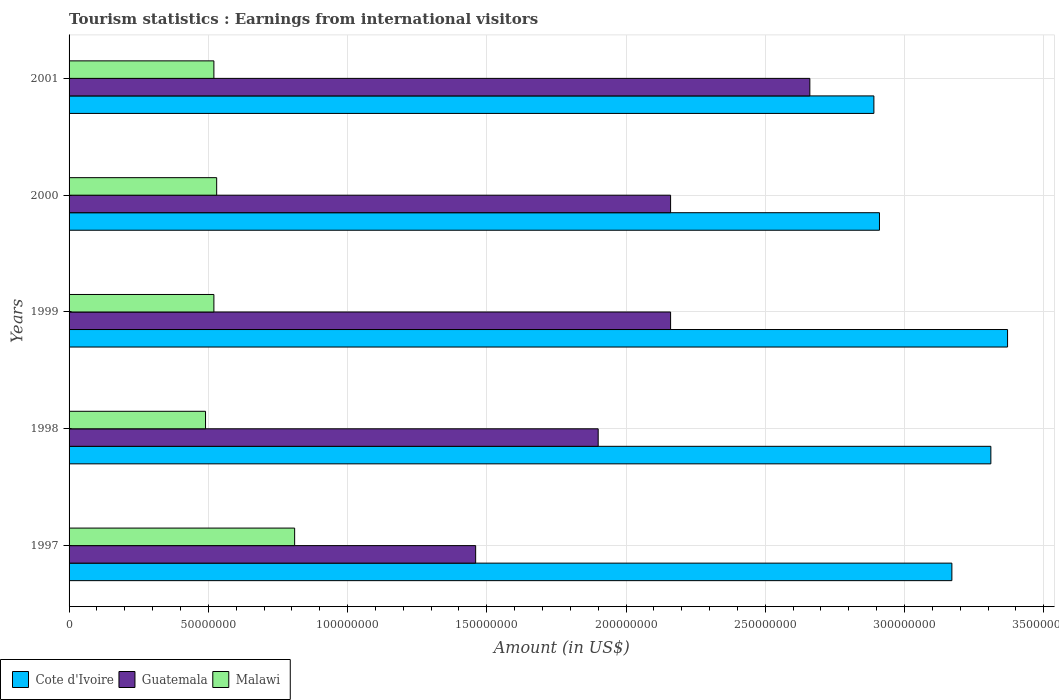How many different coloured bars are there?
Provide a succinct answer. 3. How many bars are there on the 5th tick from the top?
Your answer should be compact. 3. How many bars are there on the 3rd tick from the bottom?
Provide a short and direct response. 3. What is the earnings from international visitors in Malawi in 2000?
Your answer should be compact. 5.30e+07. Across all years, what is the maximum earnings from international visitors in Malawi?
Your answer should be compact. 8.10e+07. Across all years, what is the minimum earnings from international visitors in Malawi?
Your response must be concise. 4.90e+07. In which year was the earnings from international visitors in Malawi maximum?
Offer a terse response. 1997. What is the total earnings from international visitors in Cote d'Ivoire in the graph?
Your response must be concise. 1.56e+09. What is the difference between the earnings from international visitors in Malawi in 1997 and that in 2000?
Your response must be concise. 2.80e+07. What is the difference between the earnings from international visitors in Malawi in 1998 and the earnings from international visitors in Guatemala in 2001?
Your answer should be compact. -2.17e+08. What is the average earnings from international visitors in Cote d'Ivoire per year?
Ensure brevity in your answer.  3.13e+08. In the year 1998, what is the difference between the earnings from international visitors in Malawi and earnings from international visitors in Cote d'Ivoire?
Ensure brevity in your answer.  -2.82e+08. What is the ratio of the earnings from international visitors in Guatemala in 1998 to that in 2000?
Offer a terse response. 0.88. Is the earnings from international visitors in Cote d'Ivoire in 1998 less than that in 2001?
Make the answer very short. No. What is the difference between the highest and the lowest earnings from international visitors in Malawi?
Make the answer very short. 3.20e+07. In how many years, is the earnings from international visitors in Cote d'Ivoire greater than the average earnings from international visitors in Cote d'Ivoire taken over all years?
Ensure brevity in your answer.  3. Is the sum of the earnings from international visitors in Malawi in 2000 and 2001 greater than the maximum earnings from international visitors in Cote d'Ivoire across all years?
Give a very brief answer. No. What does the 3rd bar from the top in 2000 represents?
Give a very brief answer. Cote d'Ivoire. What does the 2nd bar from the bottom in 2000 represents?
Provide a succinct answer. Guatemala. Are all the bars in the graph horizontal?
Provide a short and direct response. Yes. How many years are there in the graph?
Offer a terse response. 5. Are the values on the major ticks of X-axis written in scientific E-notation?
Your answer should be very brief. No. Does the graph contain any zero values?
Keep it short and to the point. No. Does the graph contain grids?
Give a very brief answer. Yes. How are the legend labels stacked?
Your answer should be compact. Horizontal. What is the title of the graph?
Make the answer very short. Tourism statistics : Earnings from international visitors. What is the label or title of the Y-axis?
Ensure brevity in your answer.  Years. What is the Amount (in US$) of Cote d'Ivoire in 1997?
Give a very brief answer. 3.17e+08. What is the Amount (in US$) in Guatemala in 1997?
Provide a short and direct response. 1.46e+08. What is the Amount (in US$) of Malawi in 1997?
Make the answer very short. 8.10e+07. What is the Amount (in US$) in Cote d'Ivoire in 1998?
Your answer should be very brief. 3.31e+08. What is the Amount (in US$) of Guatemala in 1998?
Your response must be concise. 1.90e+08. What is the Amount (in US$) of Malawi in 1998?
Provide a succinct answer. 4.90e+07. What is the Amount (in US$) of Cote d'Ivoire in 1999?
Offer a terse response. 3.37e+08. What is the Amount (in US$) in Guatemala in 1999?
Your answer should be very brief. 2.16e+08. What is the Amount (in US$) of Malawi in 1999?
Offer a terse response. 5.20e+07. What is the Amount (in US$) in Cote d'Ivoire in 2000?
Provide a succinct answer. 2.91e+08. What is the Amount (in US$) of Guatemala in 2000?
Your answer should be very brief. 2.16e+08. What is the Amount (in US$) of Malawi in 2000?
Make the answer very short. 5.30e+07. What is the Amount (in US$) of Cote d'Ivoire in 2001?
Give a very brief answer. 2.89e+08. What is the Amount (in US$) in Guatemala in 2001?
Make the answer very short. 2.66e+08. What is the Amount (in US$) in Malawi in 2001?
Keep it short and to the point. 5.20e+07. Across all years, what is the maximum Amount (in US$) of Cote d'Ivoire?
Your answer should be very brief. 3.37e+08. Across all years, what is the maximum Amount (in US$) of Guatemala?
Provide a succinct answer. 2.66e+08. Across all years, what is the maximum Amount (in US$) in Malawi?
Your response must be concise. 8.10e+07. Across all years, what is the minimum Amount (in US$) of Cote d'Ivoire?
Keep it short and to the point. 2.89e+08. Across all years, what is the minimum Amount (in US$) in Guatemala?
Your answer should be compact. 1.46e+08. Across all years, what is the minimum Amount (in US$) in Malawi?
Provide a short and direct response. 4.90e+07. What is the total Amount (in US$) in Cote d'Ivoire in the graph?
Your answer should be very brief. 1.56e+09. What is the total Amount (in US$) of Guatemala in the graph?
Provide a short and direct response. 1.03e+09. What is the total Amount (in US$) of Malawi in the graph?
Offer a terse response. 2.87e+08. What is the difference between the Amount (in US$) of Cote d'Ivoire in 1997 and that in 1998?
Make the answer very short. -1.40e+07. What is the difference between the Amount (in US$) in Guatemala in 1997 and that in 1998?
Ensure brevity in your answer.  -4.40e+07. What is the difference between the Amount (in US$) in Malawi in 1997 and that in 1998?
Ensure brevity in your answer.  3.20e+07. What is the difference between the Amount (in US$) in Cote d'Ivoire in 1997 and that in 1999?
Your answer should be very brief. -2.00e+07. What is the difference between the Amount (in US$) of Guatemala in 1997 and that in 1999?
Ensure brevity in your answer.  -7.00e+07. What is the difference between the Amount (in US$) of Malawi in 1997 and that in 1999?
Offer a very short reply. 2.90e+07. What is the difference between the Amount (in US$) of Cote d'Ivoire in 1997 and that in 2000?
Ensure brevity in your answer.  2.60e+07. What is the difference between the Amount (in US$) of Guatemala in 1997 and that in 2000?
Offer a terse response. -7.00e+07. What is the difference between the Amount (in US$) in Malawi in 1997 and that in 2000?
Give a very brief answer. 2.80e+07. What is the difference between the Amount (in US$) of Cote d'Ivoire in 1997 and that in 2001?
Provide a short and direct response. 2.80e+07. What is the difference between the Amount (in US$) of Guatemala in 1997 and that in 2001?
Your answer should be compact. -1.20e+08. What is the difference between the Amount (in US$) of Malawi in 1997 and that in 2001?
Offer a very short reply. 2.90e+07. What is the difference between the Amount (in US$) of Cote d'Ivoire in 1998 and that in 1999?
Your answer should be very brief. -6.00e+06. What is the difference between the Amount (in US$) of Guatemala in 1998 and that in 1999?
Ensure brevity in your answer.  -2.60e+07. What is the difference between the Amount (in US$) of Cote d'Ivoire in 1998 and that in 2000?
Your answer should be very brief. 4.00e+07. What is the difference between the Amount (in US$) of Guatemala in 1998 and that in 2000?
Your answer should be very brief. -2.60e+07. What is the difference between the Amount (in US$) in Malawi in 1998 and that in 2000?
Offer a terse response. -4.00e+06. What is the difference between the Amount (in US$) in Cote d'Ivoire in 1998 and that in 2001?
Provide a short and direct response. 4.20e+07. What is the difference between the Amount (in US$) in Guatemala in 1998 and that in 2001?
Offer a terse response. -7.60e+07. What is the difference between the Amount (in US$) of Malawi in 1998 and that in 2001?
Your response must be concise. -3.00e+06. What is the difference between the Amount (in US$) in Cote d'Ivoire in 1999 and that in 2000?
Provide a short and direct response. 4.60e+07. What is the difference between the Amount (in US$) of Guatemala in 1999 and that in 2000?
Your answer should be compact. 0. What is the difference between the Amount (in US$) in Cote d'Ivoire in 1999 and that in 2001?
Your answer should be very brief. 4.80e+07. What is the difference between the Amount (in US$) of Guatemala in 1999 and that in 2001?
Ensure brevity in your answer.  -5.00e+07. What is the difference between the Amount (in US$) in Malawi in 1999 and that in 2001?
Your answer should be compact. 0. What is the difference between the Amount (in US$) in Cote d'Ivoire in 2000 and that in 2001?
Your answer should be very brief. 2.00e+06. What is the difference between the Amount (in US$) in Guatemala in 2000 and that in 2001?
Make the answer very short. -5.00e+07. What is the difference between the Amount (in US$) of Malawi in 2000 and that in 2001?
Your answer should be very brief. 1.00e+06. What is the difference between the Amount (in US$) in Cote d'Ivoire in 1997 and the Amount (in US$) in Guatemala in 1998?
Provide a succinct answer. 1.27e+08. What is the difference between the Amount (in US$) in Cote d'Ivoire in 1997 and the Amount (in US$) in Malawi in 1998?
Your answer should be very brief. 2.68e+08. What is the difference between the Amount (in US$) in Guatemala in 1997 and the Amount (in US$) in Malawi in 1998?
Make the answer very short. 9.70e+07. What is the difference between the Amount (in US$) in Cote d'Ivoire in 1997 and the Amount (in US$) in Guatemala in 1999?
Your response must be concise. 1.01e+08. What is the difference between the Amount (in US$) of Cote d'Ivoire in 1997 and the Amount (in US$) of Malawi in 1999?
Provide a succinct answer. 2.65e+08. What is the difference between the Amount (in US$) of Guatemala in 1997 and the Amount (in US$) of Malawi in 1999?
Your answer should be compact. 9.40e+07. What is the difference between the Amount (in US$) of Cote d'Ivoire in 1997 and the Amount (in US$) of Guatemala in 2000?
Your answer should be very brief. 1.01e+08. What is the difference between the Amount (in US$) of Cote d'Ivoire in 1997 and the Amount (in US$) of Malawi in 2000?
Offer a terse response. 2.64e+08. What is the difference between the Amount (in US$) of Guatemala in 1997 and the Amount (in US$) of Malawi in 2000?
Your answer should be very brief. 9.30e+07. What is the difference between the Amount (in US$) in Cote d'Ivoire in 1997 and the Amount (in US$) in Guatemala in 2001?
Make the answer very short. 5.10e+07. What is the difference between the Amount (in US$) in Cote d'Ivoire in 1997 and the Amount (in US$) in Malawi in 2001?
Give a very brief answer. 2.65e+08. What is the difference between the Amount (in US$) in Guatemala in 1997 and the Amount (in US$) in Malawi in 2001?
Your answer should be very brief. 9.40e+07. What is the difference between the Amount (in US$) of Cote d'Ivoire in 1998 and the Amount (in US$) of Guatemala in 1999?
Make the answer very short. 1.15e+08. What is the difference between the Amount (in US$) in Cote d'Ivoire in 1998 and the Amount (in US$) in Malawi in 1999?
Your response must be concise. 2.79e+08. What is the difference between the Amount (in US$) of Guatemala in 1998 and the Amount (in US$) of Malawi in 1999?
Ensure brevity in your answer.  1.38e+08. What is the difference between the Amount (in US$) in Cote d'Ivoire in 1998 and the Amount (in US$) in Guatemala in 2000?
Give a very brief answer. 1.15e+08. What is the difference between the Amount (in US$) in Cote d'Ivoire in 1998 and the Amount (in US$) in Malawi in 2000?
Your answer should be compact. 2.78e+08. What is the difference between the Amount (in US$) in Guatemala in 1998 and the Amount (in US$) in Malawi in 2000?
Your response must be concise. 1.37e+08. What is the difference between the Amount (in US$) of Cote d'Ivoire in 1998 and the Amount (in US$) of Guatemala in 2001?
Your answer should be compact. 6.50e+07. What is the difference between the Amount (in US$) in Cote d'Ivoire in 1998 and the Amount (in US$) in Malawi in 2001?
Keep it short and to the point. 2.79e+08. What is the difference between the Amount (in US$) of Guatemala in 1998 and the Amount (in US$) of Malawi in 2001?
Make the answer very short. 1.38e+08. What is the difference between the Amount (in US$) in Cote d'Ivoire in 1999 and the Amount (in US$) in Guatemala in 2000?
Offer a terse response. 1.21e+08. What is the difference between the Amount (in US$) in Cote d'Ivoire in 1999 and the Amount (in US$) in Malawi in 2000?
Make the answer very short. 2.84e+08. What is the difference between the Amount (in US$) in Guatemala in 1999 and the Amount (in US$) in Malawi in 2000?
Provide a succinct answer. 1.63e+08. What is the difference between the Amount (in US$) of Cote d'Ivoire in 1999 and the Amount (in US$) of Guatemala in 2001?
Keep it short and to the point. 7.10e+07. What is the difference between the Amount (in US$) in Cote d'Ivoire in 1999 and the Amount (in US$) in Malawi in 2001?
Provide a succinct answer. 2.85e+08. What is the difference between the Amount (in US$) in Guatemala in 1999 and the Amount (in US$) in Malawi in 2001?
Provide a short and direct response. 1.64e+08. What is the difference between the Amount (in US$) in Cote d'Ivoire in 2000 and the Amount (in US$) in Guatemala in 2001?
Offer a very short reply. 2.50e+07. What is the difference between the Amount (in US$) in Cote d'Ivoire in 2000 and the Amount (in US$) in Malawi in 2001?
Your response must be concise. 2.39e+08. What is the difference between the Amount (in US$) of Guatemala in 2000 and the Amount (in US$) of Malawi in 2001?
Offer a very short reply. 1.64e+08. What is the average Amount (in US$) of Cote d'Ivoire per year?
Give a very brief answer. 3.13e+08. What is the average Amount (in US$) of Guatemala per year?
Your answer should be very brief. 2.07e+08. What is the average Amount (in US$) in Malawi per year?
Provide a short and direct response. 5.74e+07. In the year 1997, what is the difference between the Amount (in US$) in Cote d'Ivoire and Amount (in US$) in Guatemala?
Provide a short and direct response. 1.71e+08. In the year 1997, what is the difference between the Amount (in US$) in Cote d'Ivoire and Amount (in US$) in Malawi?
Your response must be concise. 2.36e+08. In the year 1997, what is the difference between the Amount (in US$) of Guatemala and Amount (in US$) of Malawi?
Provide a short and direct response. 6.50e+07. In the year 1998, what is the difference between the Amount (in US$) in Cote d'Ivoire and Amount (in US$) in Guatemala?
Give a very brief answer. 1.41e+08. In the year 1998, what is the difference between the Amount (in US$) of Cote d'Ivoire and Amount (in US$) of Malawi?
Your response must be concise. 2.82e+08. In the year 1998, what is the difference between the Amount (in US$) in Guatemala and Amount (in US$) in Malawi?
Your answer should be very brief. 1.41e+08. In the year 1999, what is the difference between the Amount (in US$) in Cote d'Ivoire and Amount (in US$) in Guatemala?
Offer a terse response. 1.21e+08. In the year 1999, what is the difference between the Amount (in US$) in Cote d'Ivoire and Amount (in US$) in Malawi?
Give a very brief answer. 2.85e+08. In the year 1999, what is the difference between the Amount (in US$) in Guatemala and Amount (in US$) in Malawi?
Give a very brief answer. 1.64e+08. In the year 2000, what is the difference between the Amount (in US$) of Cote d'Ivoire and Amount (in US$) of Guatemala?
Provide a succinct answer. 7.50e+07. In the year 2000, what is the difference between the Amount (in US$) of Cote d'Ivoire and Amount (in US$) of Malawi?
Your answer should be very brief. 2.38e+08. In the year 2000, what is the difference between the Amount (in US$) in Guatemala and Amount (in US$) in Malawi?
Offer a terse response. 1.63e+08. In the year 2001, what is the difference between the Amount (in US$) of Cote d'Ivoire and Amount (in US$) of Guatemala?
Offer a terse response. 2.30e+07. In the year 2001, what is the difference between the Amount (in US$) of Cote d'Ivoire and Amount (in US$) of Malawi?
Your answer should be compact. 2.37e+08. In the year 2001, what is the difference between the Amount (in US$) of Guatemala and Amount (in US$) of Malawi?
Make the answer very short. 2.14e+08. What is the ratio of the Amount (in US$) of Cote d'Ivoire in 1997 to that in 1998?
Your answer should be very brief. 0.96. What is the ratio of the Amount (in US$) in Guatemala in 1997 to that in 1998?
Provide a succinct answer. 0.77. What is the ratio of the Amount (in US$) in Malawi in 1997 to that in 1998?
Your response must be concise. 1.65. What is the ratio of the Amount (in US$) of Cote d'Ivoire in 1997 to that in 1999?
Give a very brief answer. 0.94. What is the ratio of the Amount (in US$) of Guatemala in 1997 to that in 1999?
Make the answer very short. 0.68. What is the ratio of the Amount (in US$) of Malawi in 1997 to that in 1999?
Your answer should be very brief. 1.56. What is the ratio of the Amount (in US$) in Cote d'Ivoire in 1997 to that in 2000?
Give a very brief answer. 1.09. What is the ratio of the Amount (in US$) of Guatemala in 1997 to that in 2000?
Provide a succinct answer. 0.68. What is the ratio of the Amount (in US$) in Malawi in 1997 to that in 2000?
Ensure brevity in your answer.  1.53. What is the ratio of the Amount (in US$) of Cote d'Ivoire in 1997 to that in 2001?
Your response must be concise. 1.1. What is the ratio of the Amount (in US$) in Guatemala in 1997 to that in 2001?
Your answer should be very brief. 0.55. What is the ratio of the Amount (in US$) in Malawi in 1997 to that in 2001?
Provide a succinct answer. 1.56. What is the ratio of the Amount (in US$) in Cote d'Ivoire in 1998 to that in 1999?
Your answer should be compact. 0.98. What is the ratio of the Amount (in US$) of Guatemala in 1998 to that in 1999?
Your response must be concise. 0.88. What is the ratio of the Amount (in US$) of Malawi in 1998 to that in 1999?
Keep it short and to the point. 0.94. What is the ratio of the Amount (in US$) in Cote d'Ivoire in 1998 to that in 2000?
Your answer should be compact. 1.14. What is the ratio of the Amount (in US$) in Guatemala in 1998 to that in 2000?
Make the answer very short. 0.88. What is the ratio of the Amount (in US$) in Malawi in 1998 to that in 2000?
Provide a succinct answer. 0.92. What is the ratio of the Amount (in US$) in Cote d'Ivoire in 1998 to that in 2001?
Provide a succinct answer. 1.15. What is the ratio of the Amount (in US$) in Malawi in 1998 to that in 2001?
Ensure brevity in your answer.  0.94. What is the ratio of the Amount (in US$) in Cote d'Ivoire in 1999 to that in 2000?
Offer a terse response. 1.16. What is the ratio of the Amount (in US$) of Malawi in 1999 to that in 2000?
Give a very brief answer. 0.98. What is the ratio of the Amount (in US$) in Cote d'Ivoire in 1999 to that in 2001?
Ensure brevity in your answer.  1.17. What is the ratio of the Amount (in US$) in Guatemala in 1999 to that in 2001?
Keep it short and to the point. 0.81. What is the ratio of the Amount (in US$) in Malawi in 1999 to that in 2001?
Provide a short and direct response. 1. What is the ratio of the Amount (in US$) in Guatemala in 2000 to that in 2001?
Make the answer very short. 0.81. What is the ratio of the Amount (in US$) of Malawi in 2000 to that in 2001?
Offer a very short reply. 1.02. What is the difference between the highest and the second highest Amount (in US$) in Malawi?
Keep it short and to the point. 2.80e+07. What is the difference between the highest and the lowest Amount (in US$) of Cote d'Ivoire?
Ensure brevity in your answer.  4.80e+07. What is the difference between the highest and the lowest Amount (in US$) in Guatemala?
Make the answer very short. 1.20e+08. What is the difference between the highest and the lowest Amount (in US$) in Malawi?
Give a very brief answer. 3.20e+07. 